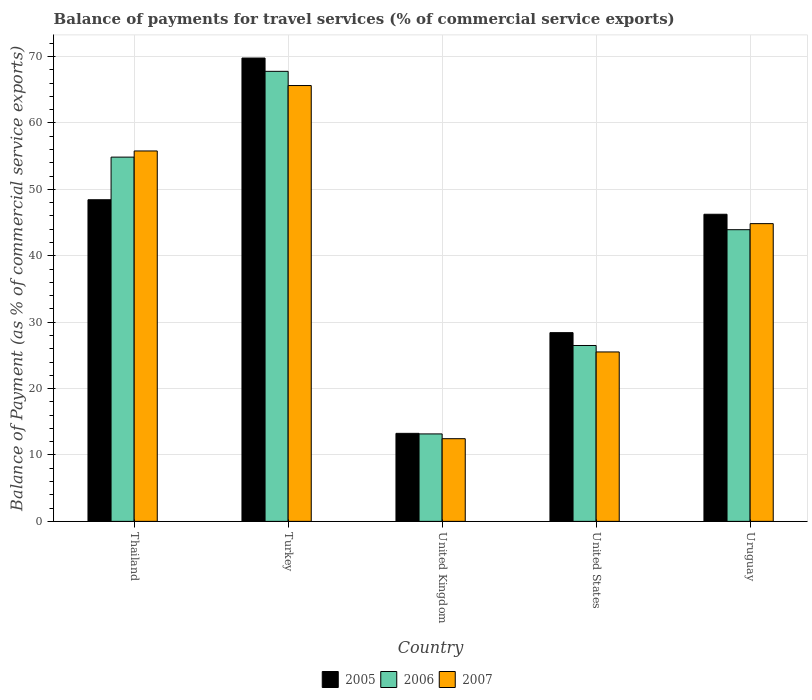Are the number of bars per tick equal to the number of legend labels?
Your response must be concise. Yes. Are the number of bars on each tick of the X-axis equal?
Ensure brevity in your answer.  Yes. How many bars are there on the 3rd tick from the left?
Offer a terse response. 3. What is the balance of payments for travel services in 2005 in Turkey?
Keep it short and to the point. 69.78. Across all countries, what is the maximum balance of payments for travel services in 2007?
Your answer should be very brief. 65.64. Across all countries, what is the minimum balance of payments for travel services in 2007?
Your answer should be compact. 12.45. In which country was the balance of payments for travel services in 2007 maximum?
Your response must be concise. Turkey. In which country was the balance of payments for travel services in 2005 minimum?
Keep it short and to the point. United Kingdom. What is the total balance of payments for travel services in 2007 in the graph?
Offer a terse response. 204.24. What is the difference between the balance of payments for travel services in 2006 in Turkey and that in Uruguay?
Ensure brevity in your answer.  23.85. What is the difference between the balance of payments for travel services in 2007 in Thailand and the balance of payments for travel services in 2006 in Turkey?
Provide a short and direct response. -11.99. What is the average balance of payments for travel services in 2007 per country?
Your answer should be very brief. 40.85. What is the difference between the balance of payments for travel services of/in 2006 and balance of payments for travel services of/in 2005 in United States?
Your response must be concise. -1.93. In how many countries, is the balance of payments for travel services in 2007 greater than 38 %?
Your answer should be very brief. 3. What is the ratio of the balance of payments for travel services in 2005 in Turkey to that in Uruguay?
Provide a succinct answer. 1.51. Is the difference between the balance of payments for travel services in 2006 in Thailand and United Kingdom greater than the difference between the balance of payments for travel services in 2005 in Thailand and United Kingdom?
Keep it short and to the point. Yes. What is the difference between the highest and the second highest balance of payments for travel services in 2005?
Your answer should be very brief. -21.34. What is the difference between the highest and the lowest balance of payments for travel services in 2005?
Provide a short and direct response. 56.52. In how many countries, is the balance of payments for travel services in 2006 greater than the average balance of payments for travel services in 2006 taken over all countries?
Offer a terse response. 3. Is the sum of the balance of payments for travel services in 2005 in Turkey and Uruguay greater than the maximum balance of payments for travel services in 2007 across all countries?
Give a very brief answer. Yes. What does the 1st bar from the right in United States represents?
Your answer should be very brief. 2007. Is it the case that in every country, the sum of the balance of payments for travel services in 2005 and balance of payments for travel services in 2007 is greater than the balance of payments for travel services in 2006?
Make the answer very short. Yes. Are all the bars in the graph horizontal?
Offer a very short reply. No. Where does the legend appear in the graph?
Offer a very short reply. Bottom center. How many legend labels are there?
Provide a short and direct response. 3. How are the legend labels stacked?
Provide a succinct answer. Horizontal. What is the title of the graph?
Keep it short and to the point. Balance of payments for travel services (% of commercial service exports). What is the label or title of the Y-axis?
Provide a short and direct response. Balance of Payment (as % of commercial service exports). What is the Balance of Payment (as % of commercial service exports) in 2005 in Thailand?
Give a very brief answer. 48.44. What is the Balance of Payment (as % of commercial service exports) in 2006 in Thailand?
Offer a very short reply. 54.86. What is the Balance of Payment (as % of commercial service exports) in 2007 in Thailand?
Provide a succinct answer. 55.79. What is the Balance of Payment (as % of commercial service exports) of 2005 in Turkey?
Your answer should be very brief. 69.78. What is the Balance of Payment (as % of commercial service exports) of 2006 in Turkey?
Make the answer very short. 67.78. What is the Balance of Payment (as % of commercial service exports) of 2007 in Turkey?
Offer a terse response. 65.64. What is the Balance of Payment (as % of commercial service exports) of 2005 in United Kingdom?
Your answer should be compact. 13.26. What is the Balance of Payment (as % of commercial service exports) of 2006 in United Kingdom?
Your response must be concise. 13.17. What is the Balance of Payment (as % of commercial service exports) of 2007 in United Kingdom?
Provide a short and direct response. 12.45. What is the Balance of Payment (as % of commercial service exports) in 2005 in United States?
Give a very brief answer. 28.42. What is the Balance of Payment (as % of commercial service exports) of 2006 in United States?
Your answer should be compact. 26.49. What is the Balance of Payment (as % of commercial service exports) of 2007 in United States?
Provide a succinct answer. 25.52. What is the Balance of Payment (as % of commercial service exports) of 2005 in Uruguay?
Offer a very short reply. 46.25. What is the Balance of Payment (as % of commercial service exports) of 2006 in Uruguay?
Make the answer very short. 43.93. What is the Balance of Payment (as % of commercial service exports) of 2007 in Uruguay?
Keep it short and to the point. 44.84. Across all countries, what is the maximum Balance of Payment (as % of commercial service exports) in 2005?
Your answer should be very brief. 69.78. Across all countries, what is the maximum Balance of Payment (as % of commercial service exports) of 2006?
Your answer should be very brief. 67.78. Across all countries, what is the maximum Balance of Payment (as % of commercial service exports) in 2007?
Make the answer very short. 65.64. Across all countries, what is the minimum Balance of Payment (as % of commercial service exports) in 2005?
Ensure brevity in your answer.  13.26. Across all countries, what is the minimum Balance of Payment (as % of commercial service exports) of 2006?
Offer a very short reply. 13.17. Across all countries, what is the minimum Balance of Payment (as % of commercial service exports) of 2007?
Offer a very short reply. 12.45. What is the total Balance of Payment (as % of commercial service exports) in 2005 in the graph?
Your response must be concise. 206.15. What is the total Balance of Payment (as % of commercial service exports) in 2006 in the graph?
Keep it short and to the point. 206.22. What is the total Balance of Payment (as % of commercial service exports) of 2007 in the graph?
Make the answer very short. 204.24. What is the difference between the Balance of Payment (as % of commercial service exports) of 2005 in Thailand and that in Turkey?
Your response must be concise. -21.34. What is the difference between the Balance of Payment (as % of commercial service exports) of 2006 in Thailand and that in Turkey?
Your answer should be compact. -12.92. What is the difference between the Balance of Payment (as % of commercial service exports) of 2007 in Thailand and that in Turkey?
Make the answer very short. -9.85. What is the difference between the Balance of Payment (as % of commercial service exports) of 2005 in Thailand and that in United Kingdom?
Give a very brief answer. 35.18. What is the difference between the Balance of Payment (as % of commercial service exports) of 2006 in Thailand and that in United Kingdom?
Provide a succinct answer. 41.69. What is the difference between the Balance of Payment (as % of commercial service exports) in 2007 in Thailand and that in United Kingdom?
Keep it short and to the point. 43.34. What is the difference between the Balance of Payment (as % of commercial service exports) in 2005 in Thailand and that in United States?
Keep it short and to the point. 20.02. What is the difference between the Balance of Payment (as % of commercial service exports) of 2006 in Thailand and that in United States?
Your answer should be compact. 28.37. What is the difference between the Balance of Payment (as % of commercial service exports) of 2007 in Thailand and that in United States?
Your answer should be very brief. 30.27. What is the difference between the Balance of Payment (as % of commercial service exports) of 2005 in Thailand and that in Uruguay?
Keep it short and to the point. 2.19. What is the difference between the Balance of Payment (as % of commercial service exports) of 2006 in Thailand and that in Uruguay?
Your answer should be compact. 10.93. What is the difference between the Balance of Payment (as % of commercial service exports) in 2007 in Thailand and that in Uruguay?
Provide a short and direct response. 10.94. What is the difference between the Balance of Payment (as % of commercial service exports) in 2005 in Turkey and that in United Kingdom?
Your answer should be compact. 56.52. What is the difference between the Balance of Payment (as % of commercial service exports) of 2006 in Turkey and that in United Kingdom?
Your response must be concise. 54.61. What is the difference between the Balance of Payment (as % of commercial service exports) in 2007 in Turkey and that in United Kingdom?
Your answer should be very brief. 53.19. What is the difference between the Balance of Payment (as % of commercial service exports) in 2005 in Turkey and that in United States?
Provide a short and direct response. 41.36. What is the difference between the Balance of Payment (as % of commercial service exports) of 2006 in Turkey and that in United States?
Your answer should be very brief. 41.29. What is the difference between the Balance of Payment (as % of commercial service exports) of 2007 in Turkey and that in United States?
Ensure brevity in your answer.  40.12. What is the difference between the Balance of Payment (as % of commercial service exports) in 2005 in Turkey and that in Uruguay?
Your answer should be compact. 23.53. What is the difference between the Balance of Payment (as % of commercial service exports) in 2006 in Turkey and that in Uruguay?
Provide a succinct answer. 23.85. What is the difference between the Balance of Payment (as % of commercial service exports) of 2007 in Turkey and that in Uruguay?
Keep it short and to the point. 20.8. What is the difference between the Balance of Payment (as % of commercial service exports) in 2005 in United Kingdom and that in United States?
Your response must be concise. -15.17. What is the difference between the Balance of Payment (as % of commercial service exports) in 2006 in United Kingdom and that in United States?
Offer a very short reply. -13.32. What is the difference between the Balance of Payment (as % of commercial service exports) in 2007 in United Kingdom and that in United States?
Provide a succinct answer. -13.06. What is the difference between the Balance of Payment (as % of commercial service exports) in 2005 in United Kingdom and that in Uruguay?
Give a very brief answer. -33. What is the difference between the Balance of Payment (as % of commercial service exports) in 2006 in United Kingdom and that in Uruguay?
Offer a very short reply. -30.76. What is the difference between the Balance of Payment (as % of commercial service exports) of 2007 in United Kingdom and that in Uruguay?
Your answer should be compact. -32.39. What is the difference between the Balance of Payment (as % of commercial service exports) of 2005 in United States and that in Uruguay?
Give a very brief answer. -17.83. What is the difference between the Balance of Payment (as % of commercial service exports) of 2006 in United States and that in Uruguay?
Make the answer very short. -17.44. What is the difference between the Balance of Payment (as % of commercial service exports) in 2007 in United States and that in Uruguay?
Your response must be concise. -19.33. What is the difference between the Balance of Payment (as % of commercial service exports) in 2005 in Thailand and the Balance of Payment (as % of commercial service exports) in 2006 in Turkey?
Offer a very short reply. -19.34. What is the difference between the Balance of Payment (as % of commercial service exports) of 2005 in Thailand and the Balance of Payment (as % of commercial service exports) of 2007 in Turkey?
Your response must be concise. -17.2. What is the difference between the Balance of Payment (as % of commercial service exports) of 2006 in Thailand and the Balance of Payment (as % of commercial service exports) of 2007 in Turkey?
Your response must be concise. -10.78. What is the difference between the Balance of Payment (as % of commercial service exports) of 2005 in Thailand and the Balance of Payment (as % of commercial service exports) of 2006 in United Kingdom?
Your response must be concise. 35.27. What is the difference between the Balance of Payment (as % of commercial service exports) of 2005 in Thailand and the Balance of Payment (as % of commercial service exports) of 2007 in United Kingdom?
Your answer should be compact. 35.99. What is the difference between the Balance of Payment (as % of commercial service exports) of 2006 in Thailand and the Balance of Payment (as % of commercial service exports) of 2007 in United Kingdom?
Provide a succinct answer. 42.41. What is the difference between the Balance of Payment (as % of commercial service exports) of 2005 in Thailand and the Balance of Payment (as % of commercial service exports) of 2006 in United States?
Give a very brief answer. 21.95. What is the difference between the Balance of Payment (as % of commercial service exports) in 2005 in Thailand and the Balance of Payment (as % of commercial service exports) in 2007 in United States?
Make the answer very short. 22.92. What is the difference between the Balance of Payment (as % of commercial service exports) in 2006 in Thailand and the Balance of Payment (as % of commercial service exports) in 2007 in United States?
Make the answer very short. 29.34. What is the difference between the Balance of Payment (as % of commercial service exports) of 2005 in Thailand and the Balance of Payment (as % of commercial service exports) of 2006 in Uruguay?
Offer a terse response. 4.51. What is the difference between the Balance of Payment (as % of commercial service exports) of 2005 in Thailand and the Balance of Payment (as % of commercial service exports) of 2007 in Uruguay?
Your answer should be compact. 3.6. What is the difference between the Balance of Payment (as % of commercial service exports) of 2006 in Thailand and the Balance of Payment (as % of commercial service exports) of 2007 in Uruguay?
Make the answer very short. 10.02. What is the difference between the Balance of Payment (as % of commercial service exports) in 2005 in Turkey and the Balance of Payment (as % of commercial service exports) in 2006 in United Kingdom?
Your answer should be very brief. 56.61. What is the difference between the Balance of Payment (as % of commercial service exports) of 2005 in Turkey and the Balance of Payment (as % of commercial service exports) of 2007 in United Kingdom?
Provide a succinct answer. 57.33. What is the difference between the Balance of Payment (as % of commercial service exports) of 2006 in Turkey and the Balance of Payment (as % of commercial service exports) of 2007 in United Kingdom?
Your answer should be very brief. 55.33. What is the difference between the Balance of Payment (as % of commercial service exports) in 2005 in Turkey and the Balance of Payment (as % of commercial service exports) in 2006 in United States?
Provide a short and direct response. 43.29. What is the difference between the Balance of Payment (as % of commercial service exports) of 2005 in Turkey and the Balance of Payment (as % of commercial service exports) of 2007 in United States?
Give a very brief answer. 44.26. What is the difference between the Balance of Payment (as % of commercial service exports) of 2006 in Turkey and the Balance of Payment (as % of commercial service exports) of 2007 in United States?
Provide a succinct answer. 42.26. What is the difference between the Balance of Payment (as % of commercial service exports) of 2005 in Turkey and the Balance of Payment (as % of commercial service exports) of 2006 in Uruguay?
Your answer should be very brief. 25.85. What is the difference between the Balance of Payment (as % of commercial service exports) of 2005 in Turkey and the Balance of Payment (as % of commercial service exports) of 2007 in Uruguay?
Give a very brief answer. 24.94. What is the difference between the Balance of Payment (as % of commercial service exports) of 2006 in Turkey and the Balance of Payment (as % of commercial service exports) of 2007 in Uruguay?
Your response must be concise. 22.94. What is the difference between the Balance of Payment (as % of commercial service exports) in 2005 in United Kingdom and the Balance of Payment (as % of commercial service exports) in 2006 in United States?
Ensure brevity in your answer.  -13.23. What is the difference between the Balance of Payment (as % of commercial service exports) of 2005 in United Kingdom and the Balance of Payment (as % of commercial service exports) of 2007 in United States?
Your answer should be very brief. -12.26. What is the difference between the Balance of Payment (as % of commercial service exports) in 2006 in United Kingdom and the Balance of Payment (as % of commercial service exports) in 2007 in United States?
Your answer should be very brief. -12.34. What is the difference between the Balance of Payment (as % of commercial service exports) in 2005 in United Kingdom and the Balance of Payment (as % of commercial service exports) in 2006 in Uruguay?
Offer a very short reply. -30.67. What is the difference between the Balance of Payment (as % of commercial service exports) in 2005 in United Kingdom and the Balance of Payment (as % of commercial service exports) in 2007 in Uruguay?
Your answer should be very brief. -31.59. What is the difference between the Balance of Payment (as % of commercial service exports) of 2006 in United Kingdom and the Balance of Payment (as % of commercial service exports) of 2007 in Uruguay?
Offer a terse response. -31.67. What is the difference between the Balance of Payment (as % of commercial service exports) in 2005 in United States and the Balance of Payment (as % of commercial service exports) in 2006 in Uruguay?
Your answer should be very brief. -15.51. What is the difference between the Balance of Payment (as % of commercial service exports) of 2005 in United States and the Balance of Payment (as % of commercial service exports) of 2007 in Uruguay?
Provide a succinct answer. -16.42. What is the difference between the Balance of Payment (as % of commercial service exports) in 2006 in United States and the Balance of Payment (as % of commercial service exports) in 2007 in Uruguay?
Ensure brevity in your answer.  -18.36. What is the average Balance of Payment (as % of commercial service exports) in 2005 per country?
Your answer should be very brief. 41.23. What is the average Balance of Payment (as % of commercial service exports) of 2006 per country?
Provide a short and direct response. 41.24. What is the average Balance of Payment (as % of commercial service exports) of 2007 per country?
Your answer should be very brief. 40.85. What is the difference between the Balance of Payment (as % of commercial service exports) of 2005 and Balance of Payment (as % of commercial service exports) of 2006 in Thailand?
Offer a terse response. -6.42. What is the difference between the Balance of Payment (as % of commercial service exports) of 2005 and Balance of Payment (as % of commercial service exports) of 2007 in Thailand?
Keep it short and to the point. -7.35. What is the difference between the Balance of Payment (as % of commercial service exports) in 2006 and Balance of Payment (as % of commercial service exports) in 2007 in Thailand?
Your answer should be very brief. -0.93. What is the difference between the Balance of Payment (as % of commercial service exports) in 2005 and Balance of Payment (as % of commercial service exports) in 2006 in Turkey?
Your response must be concise. 2. What is the difference between the Balance of Payment (as % of commercial service exports) of 2005 and Balance of Payment (as % of commercial service exports) of 2007 in Turkey?
Provide a short and direct response. 4.14. What is the difference between the Balance of Payment (as % of commercial service exports) of 2006 and Balance of Payment (as % of commercial service exports) of 2007 in Turkey?
Your answer should be compact. 2.14. What is the difference between the Balance of Payment (as % of commercial service exports) in 2005 and Balance of Payment (as % of commercial service exports) in 2006 in United Kingdom?
Offer a very short reply. 0.08. What is the difference between the Balance of Payment (as % of commercial service exports) in 2005 and Balance of Payment (as % of commercial service exports) in 2007 in United Kingdom?
Offer a very short reply. 0.8. What is the difference between the Balance of Payment (as % of commercial service exports) in 2006 and Balance of Payment (as % of commercial service exports) in 2007 in United Kingdom?
Provide a short and direct response. 0.72. What is the difference between the Balance of Payment (as % of commercial service exports) of 2005 and Balance of Payment (as % of commercial service exports) of 2006 in United States?
Ensure brevity in your answer.  1.93. What is the difference between the Balance of Payment (as % of commercial service exports) in 2005 and Balance of Payment (as % of commercial service exports) in 2007 in United States?
Ensure brevity in your answer.  2.91. What is the difference between the Balance of Payment (as % of commercial service exports) in 2006 and Balance of Payment (as % of commercial service exports) in 2007 in United States?
Ensure brevity in your answer.  0.97. What is the difference between the Balance of Payment (as % of commercial service exports) of 2005 and Balance of Payment (as % of commercial service exports) of 2006 in Uruguay?
Provide a short and direct response. 2.32. What is the difference between the Balance of Payment (as % of commercial service exports) in 2005 and Balance of Payment (as % of commercial service exports) in 2007 in Uruguay?
Keep it short and to the point. 1.41. What is the difference between the Balance of Payment (as % of commercial service exports) in 2006 and Balance of Payment (as % of commercial service exports) in 2007 in Uruguay?
Keep it short and to the point. -0.91. What is the ratio of the Balance of Payment (as % of commercial service exports) in 2005 in Thailand to that in Turkey?
Ensure brevity in your answer.  0.69. What is the ratio of the Balance of Payment (as % of commercial service exports) of 2006 in Thailand to that in Turkey?
Your answer should be very brief. 0.81. What is the ratio of the Balance of Payment (as % of commercial service exports) of 2007 in Thailand to that in Turkey?
Your answer should be very brief. 0.85. What is the ratio of the Balance of Payment (as % of commercial service exports) in 2005 in Thailand to that in United Kingdom?
Your answer should be very brief. 3.65. What is the ratio of the Balance of Payment (as % of commercial service exports) of 2006 in Thailand to that in United Kingdom?
Your response must be concise. 4.16. What is the ratio of the Balance of Payment (as % of commercial service exports) of 2007 in Thailand to that in United Kingdom?
Provide a short and direct response. 4.48. What is the ratio of the Balance of Payment (as % of commercial service exports) in 2005 in Thailand to that in United States?
Provide a short and direct response. 1.7. What is the ratio of the Balance of Payment (as % of commercial service exports) in 2006 in Thailand to that in United States?
Make the answer very short. 2.07. What is the ratio of the Balance of Payment (as % of commercial service exports) in 2007 in Thailand to that in United States?
Provide a succinct answer. 2.19. What is the ratio of the Balance of Payment (as % of commercial service exports) in 2005 in Thailand to that in Uruguay?
Provide a succinct answer. 1.05. What is the ratio of the Balance of Payment (as % of commercial service exports) in 2006 in Thailand to that in Uruguay?
Provide a short and direct response. 1.25. What is the ratio of the Balance of Payment (as % of commercial service exports) in 2007 in Thailand to that in Uruguay?
Keep it short and to the point. 1.24. What is the ratio of the Balance of Payment (as % of commercial service exports) of 2005 in Turkey to that in United Kingdom?
Ensure brevity in your answer.  5.26. What is the ratio of the Balance of Payment (as % of commercial service exports) in 2006 in Turkey to that in United Kingdom?
Your response must be concise. 5.15. What is the ratio of the Balance of Payment (as % of commercial service exports) of 2007 in Turkey to that in United Kingdom?
Ensure brevity in your answer.  5.27. What is the ratio of the Balance of Payment (as % of commercial service exports) of 2005 in Turkey to that in United States?
Provide a short and direct response. 2.46. What is the ratio of the Balance of Payment (as % of commercial service exports) in 2006 in Turkey to that in United States?
Your response must be concise. 2.56. What is the ratio of the Balance of Payment (as % of commercial service exports) in 2007 in Turkey to that in United States?
Your answer should be compact. 2.57. What is the ratio of the Balance of Payment (as % of commercial service exports) of 2005 in Turkey to that in Uruguay?
Ensure brevity in your answer.  1.51. What is the ratio of the Balance of Payment (as % of commercial service exports) in 2006 in Turkey to that in Uruguay?
Your answer should be compact. 1.54. What is the ratio of the Balance of Payment (as % of commercial service exports) of 2007 in Turkey to that in Uruguay?
Your response must be concise. 1.46. What is the ratio of the Balance of Payment (as % of commercial service exports) in 2005 in United Kingdom to that in United States?
Offer a very short reply. 0.47. What is the ratio of the Balance of Payment (as % of commercial service exports) in 2006 in United Kingdom to that in United States?
Make the answer very short. 0.5. What is the ratio of the Balance of Payment (as % of commercial service exports) in 2007 in United Kingdom to that in United States?
Give a very brief answer. 0.49. What is the ratio of the Balance of Payment (as % of commercial service exports) of 2005 in United Kingdom to that in Uruguay?
Give a very brief answer. 0.29. What is the ratio of the Balance of Payment (as % of commercial service exports) of 2006 in United Kingdom to that in Uruguay?
Provide a short and direct response. 0.3. What is the ratio of the Balance of Payment (as % of commercial service exports) of 2007 in United Kingdom to that in Uruguay?
Ensure brevity in your answer.  0.28. What is the ratio of the Balance of Payment (as % of commercial service exports) of 2005 in United States to that in Uruguay?
Give a very brief answer. 0.61. What is the ratio of the Balance of Payment (as % of commercial service exports) in 2006 in United States to that in Uruguay?
Your answer should be very brief. 0.6. What is the ratio of the Balance of Payment (as % of commercial service exports) of 2007 in United States to that in Uruguay?
Offer a terse response. 0.57. What is the difference between the highest and the second highest Balance of Payment (as % of commercial service exports) of 2005?
Offer a terse response. 21.34. What is the difference between the highest and the second highest Balance of Payment (as % of commercial service exports) in 2006?
Offer a very short reply. 12.92. What is the difference between the highest and the second highest Balance of Payment (as % of commercial service exports) of 2007?
Your answer should be very brief. 9.85. What is the difference between the highest and the lowest Balance of Payment (as % of commercial service exports) in 2005?
Your answer should be compact. 56.52. What is the difference between the highest and the lowest Balance of Payment (as % of commercial service exports) in 2006?
Provide a short and direct response. 54.61. What is the difference between the highest and the lowest Balance of Payment (as % of commercial service exports) in 2007?
Your answer should be very brief. 53.19. 